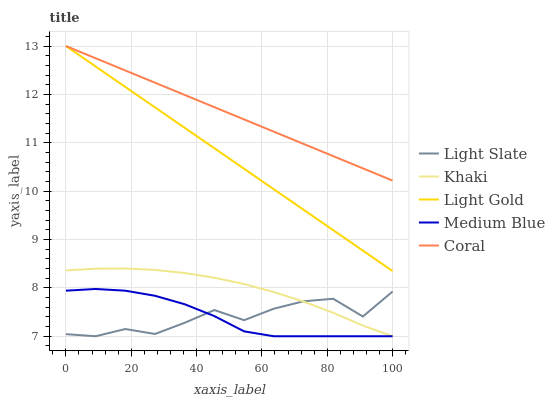Does Light Slate have the minimum area under the curve?
Answer yes or no. Yes. Does Coral have the maximum area under the curve?
Answer yes or no. Yes. Does Medium Blue have the minimum area under the curve?
Answer yes or no. No. Does Medium Blue have the maximum area under the curve?
Answer yes or no. No. Is Light Gold the smoothest?
Answer yes or no. Yes. Is Light Slate the roughest?
Answer yes or no. Yes. Is Medium Blue the smoothest?
Answer yes or no. No. Is Medium Blue the roughest?
Answer yes or no. No. Does Light Slate have the lowest value?
Answer yes or no. Yes. Does Coral have the lowest value?
Answer yes or no. No. Does Light Gold have the highest value?
Answer yes or no. Yes. Does Medium Blue have the highest value?
Answer yes or no. No. Is Medium Blue less than Light Gold?
Answer yes or no. Yes. Is Coral greater than Medium Blue?
Answer yes or no. Yes. Does Light Slate intersect Khaki?
Answer yes or no. Yes. Is Light Slate less than Khaki?
Answer yes or no. No. Is Light Slate greater than Khaki?
Answer yes or no. No. Does Medium Blue intersect Light Gold?
Answer yes or no. No. 